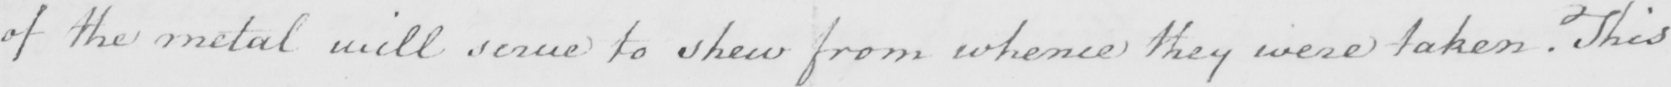Please provide the text content of this handwritten line. of the metal will serve to shew from whence they were taken . This 